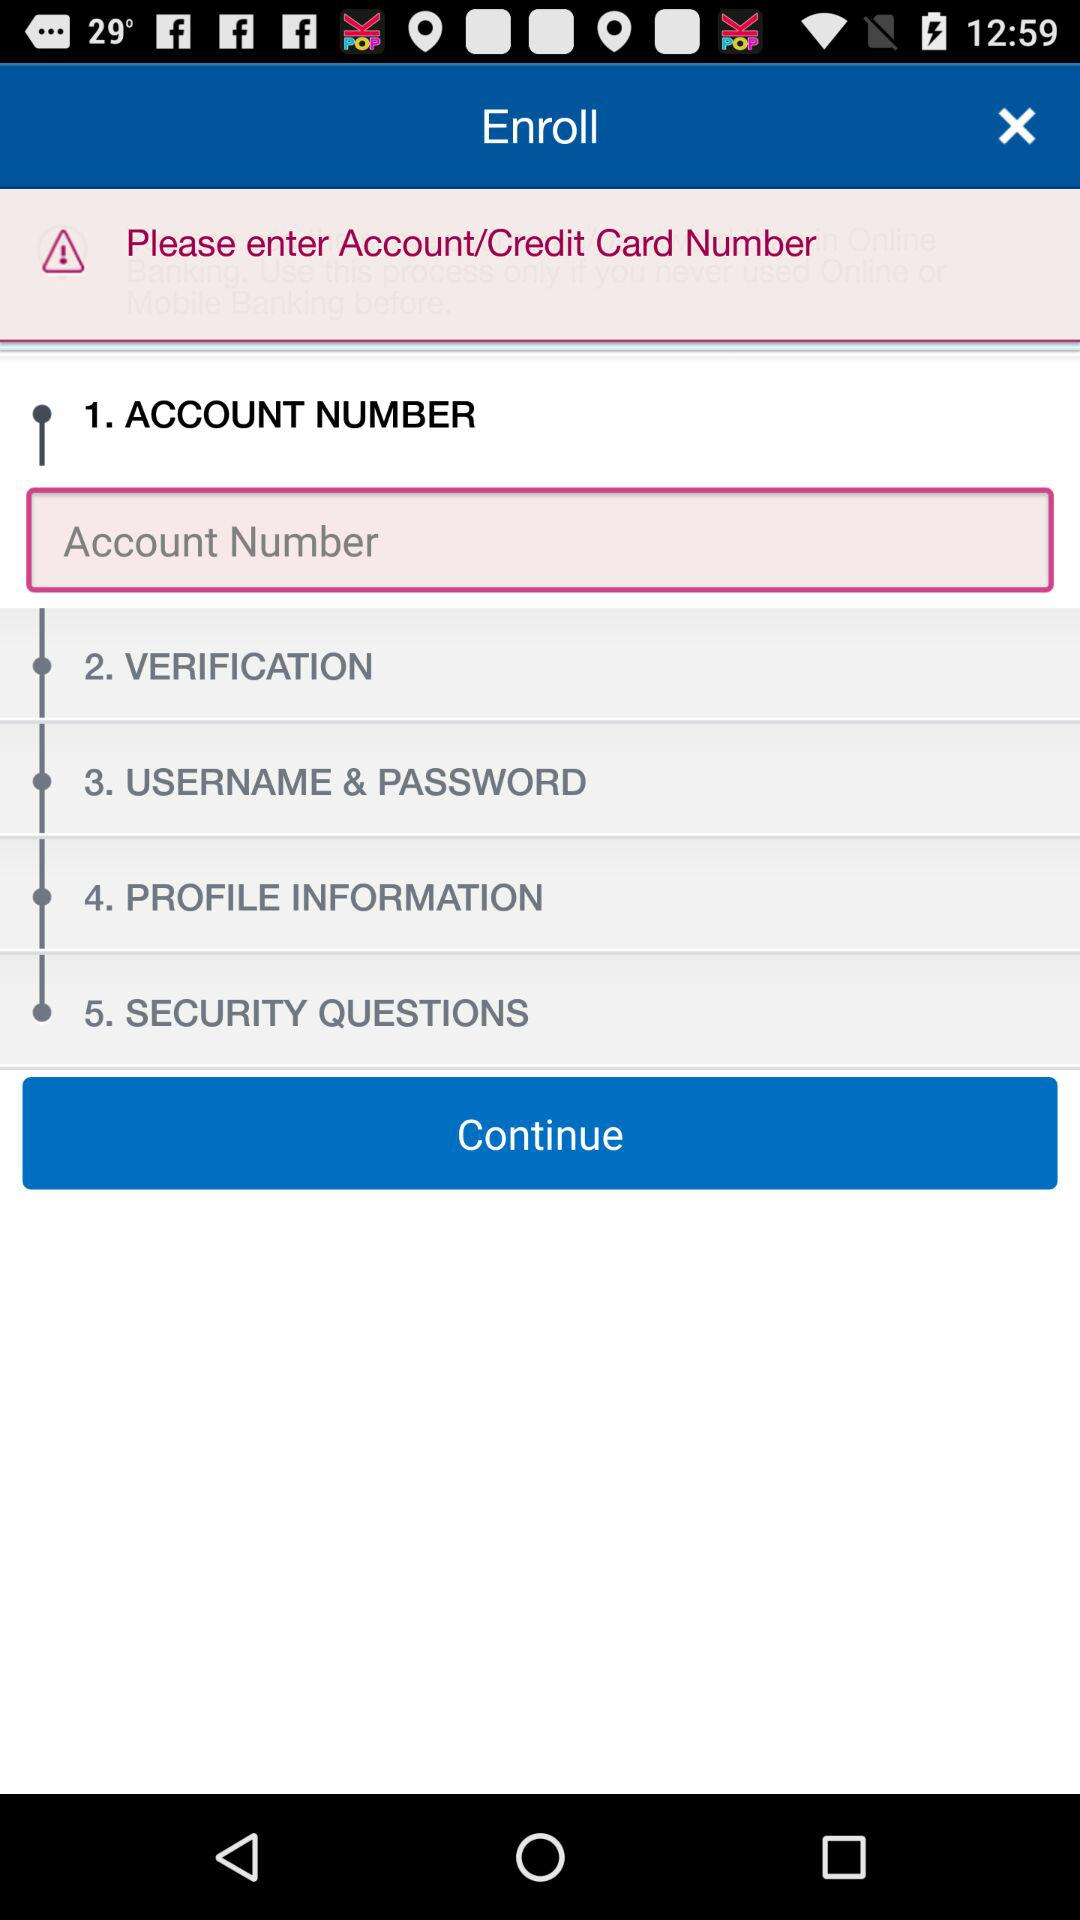What is step one? The step one is "ACCOUNT NUMBER". 